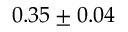<formula> <loc_0><loc_0><loc_500><loc_500>0 . 3 5 \pm 0 . 0 4</formula> 